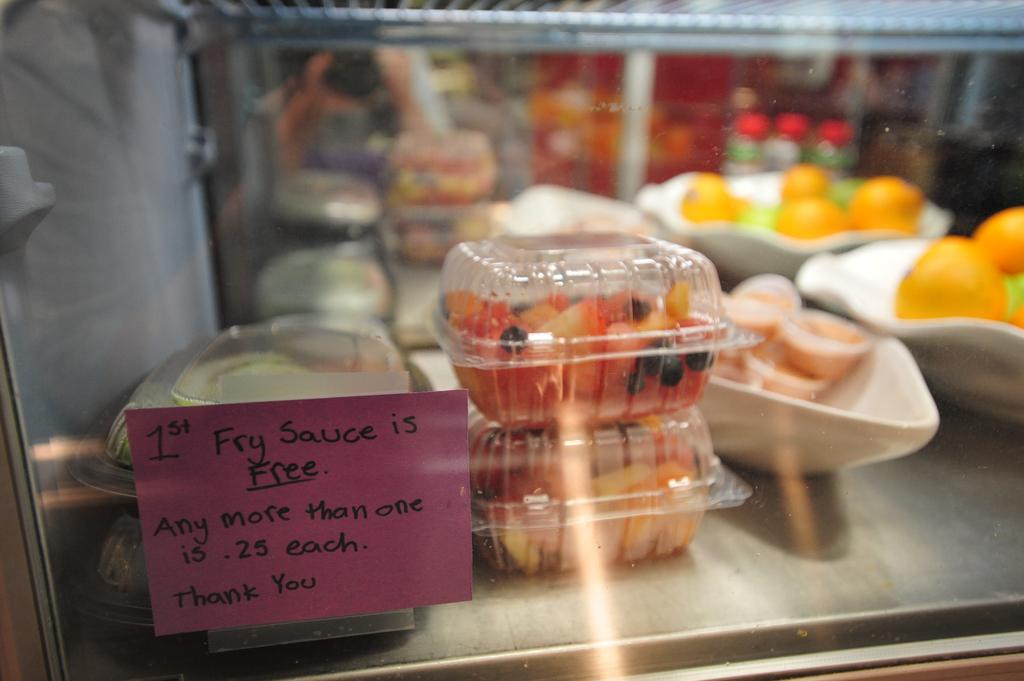What object is present in the image that can hold liquid? There is a glass in the image. What can be seen through the glass? Fruits and food items are visible through the glass. How are the food items arranged in the image? The food items are in a bowl. What type of holiday is being celebrated in the image? There is no indication of a holiday being celebrated in the image. 